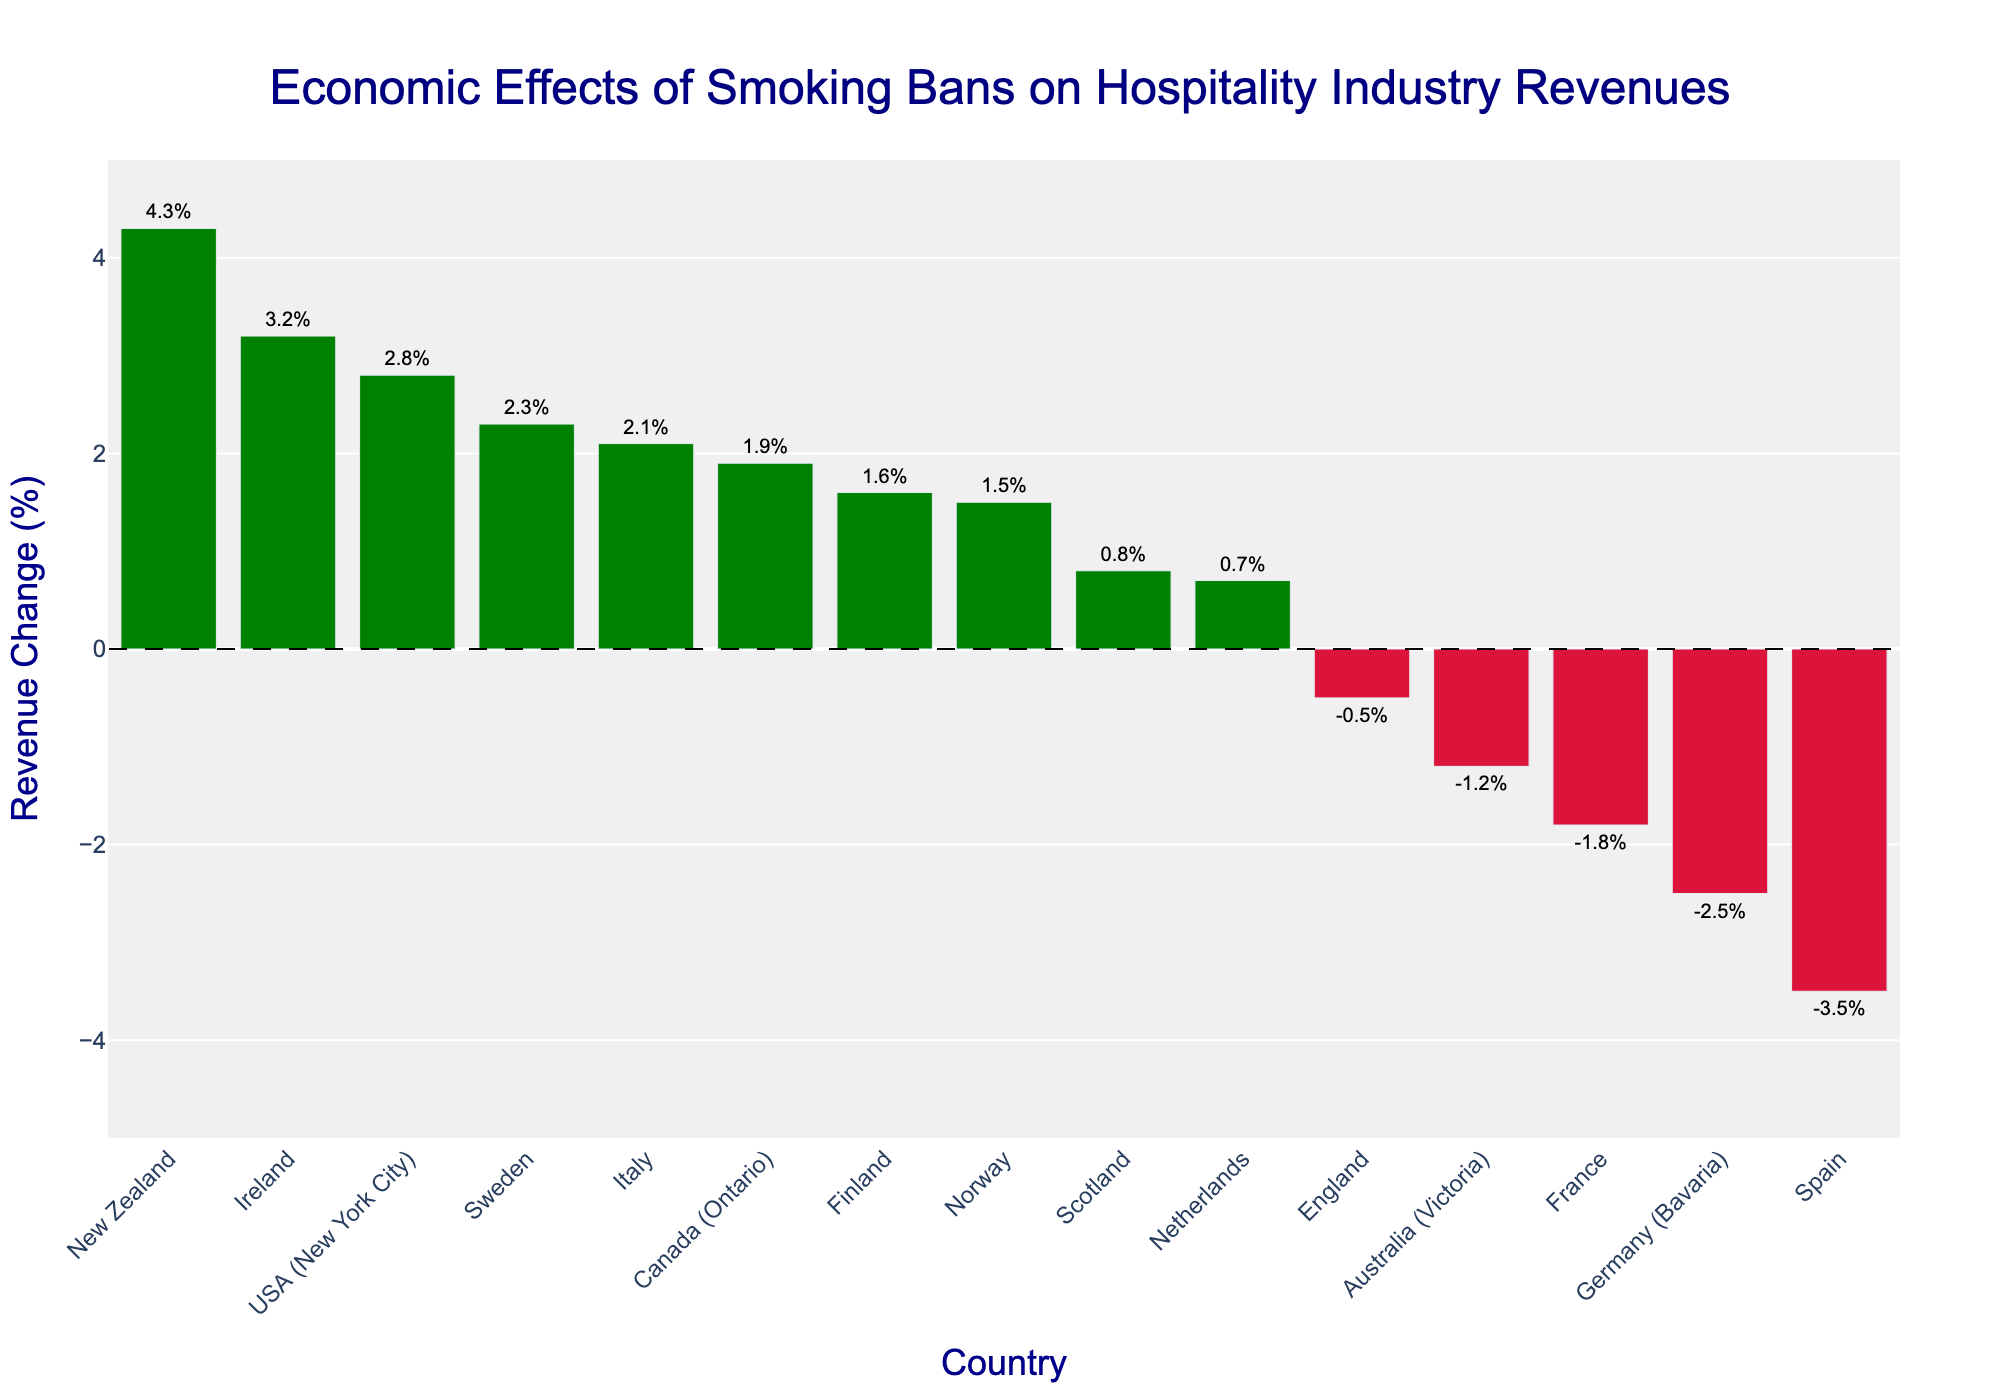What's the country with the highest increase in revenue after the smoking ban? Sort the countries by their revenue change percentages. The highest positive increase is 4.3%, which belongs to New Zealand.
Answer: New Zealand Which countries experienced a decrease in revenue after the ban? Look for the bars that are in red, indicating a negative revenue change. The countries are England, Australia (Victoria), Spain, France, and Germany (Bavaria).
Answer: England, Australia (Victoria), Spain, France, Germany (Bavaria) What's the overall range of revenue changes depicted in the chart? Identify the maximum and minimum revenue changes. The highest is +4.3% (New Zealand) and the lowest is -3.5% (Spain). The range is 4.3% - (-3.5%) = 7.8%.
Answer: 7.8% Which country implemented the smoking ban in the earliest year shown on the chart? Look at the hover text for each country, which shows the year of ban implementation. The earliest year is 2003, for the USA (New York City).
Answer: USA (New York City) How many countries had a positive revenue change after the smoking ban? Count the number of bars colored in green, which represent positive revenue changes. There are 10 such bars.
Answer: 10 Between Finland and Spain, which country had a more positive reaction in terms of revenue change after the ban? Compare the revenue changes for Finland (+1.6%) and Spain (-3.5%). Finland's change is more positive.
Answer: Finland What's the median revenue change among all the countries listed? Order the revenue changes and find the middle value. The ordered changes are: -3.5, -2.5, -1.8, -1.2, -0.5, +0.7, +0.8, +1.5, +1.6, +1.9, +2.1, +2.3, +2.8, +3.2, +4.3. The middle value (8th in order) is +1.5%.
Answer: +1.5% Was the economic impact more positive or negative overall in terms of the number of countries? Compare the number of positive changes (green bars) to the number of negative changes (red bars). There are 10 positive and 5 negative changes, so overall it was more positive.
Answer: More positive Which countries implemented smoking bans in 2007, and what were their revenue changes? Hover over the bars to see the implementation year. The countries are England (-0.5%), Australia (Victoria) (-1.2%), and Finland (+1.6%).
Answer: England, Australia (Victoria), Finland On average, how did revenues change after the implementation of smoking bans? Calculate the average of the revenue changes. Sum all the changes and divide by the total number of countries: (3.2 + 0.8 - 0.5 + 1.5 + 2.1 + 4.3 + 1.9 + 2.8 - 1.2 - 3.5 + 0.7 + 1.6 + 2.3 - 1.8 - 2.5)/15 = 0.91%.
Answer: +0.91% 